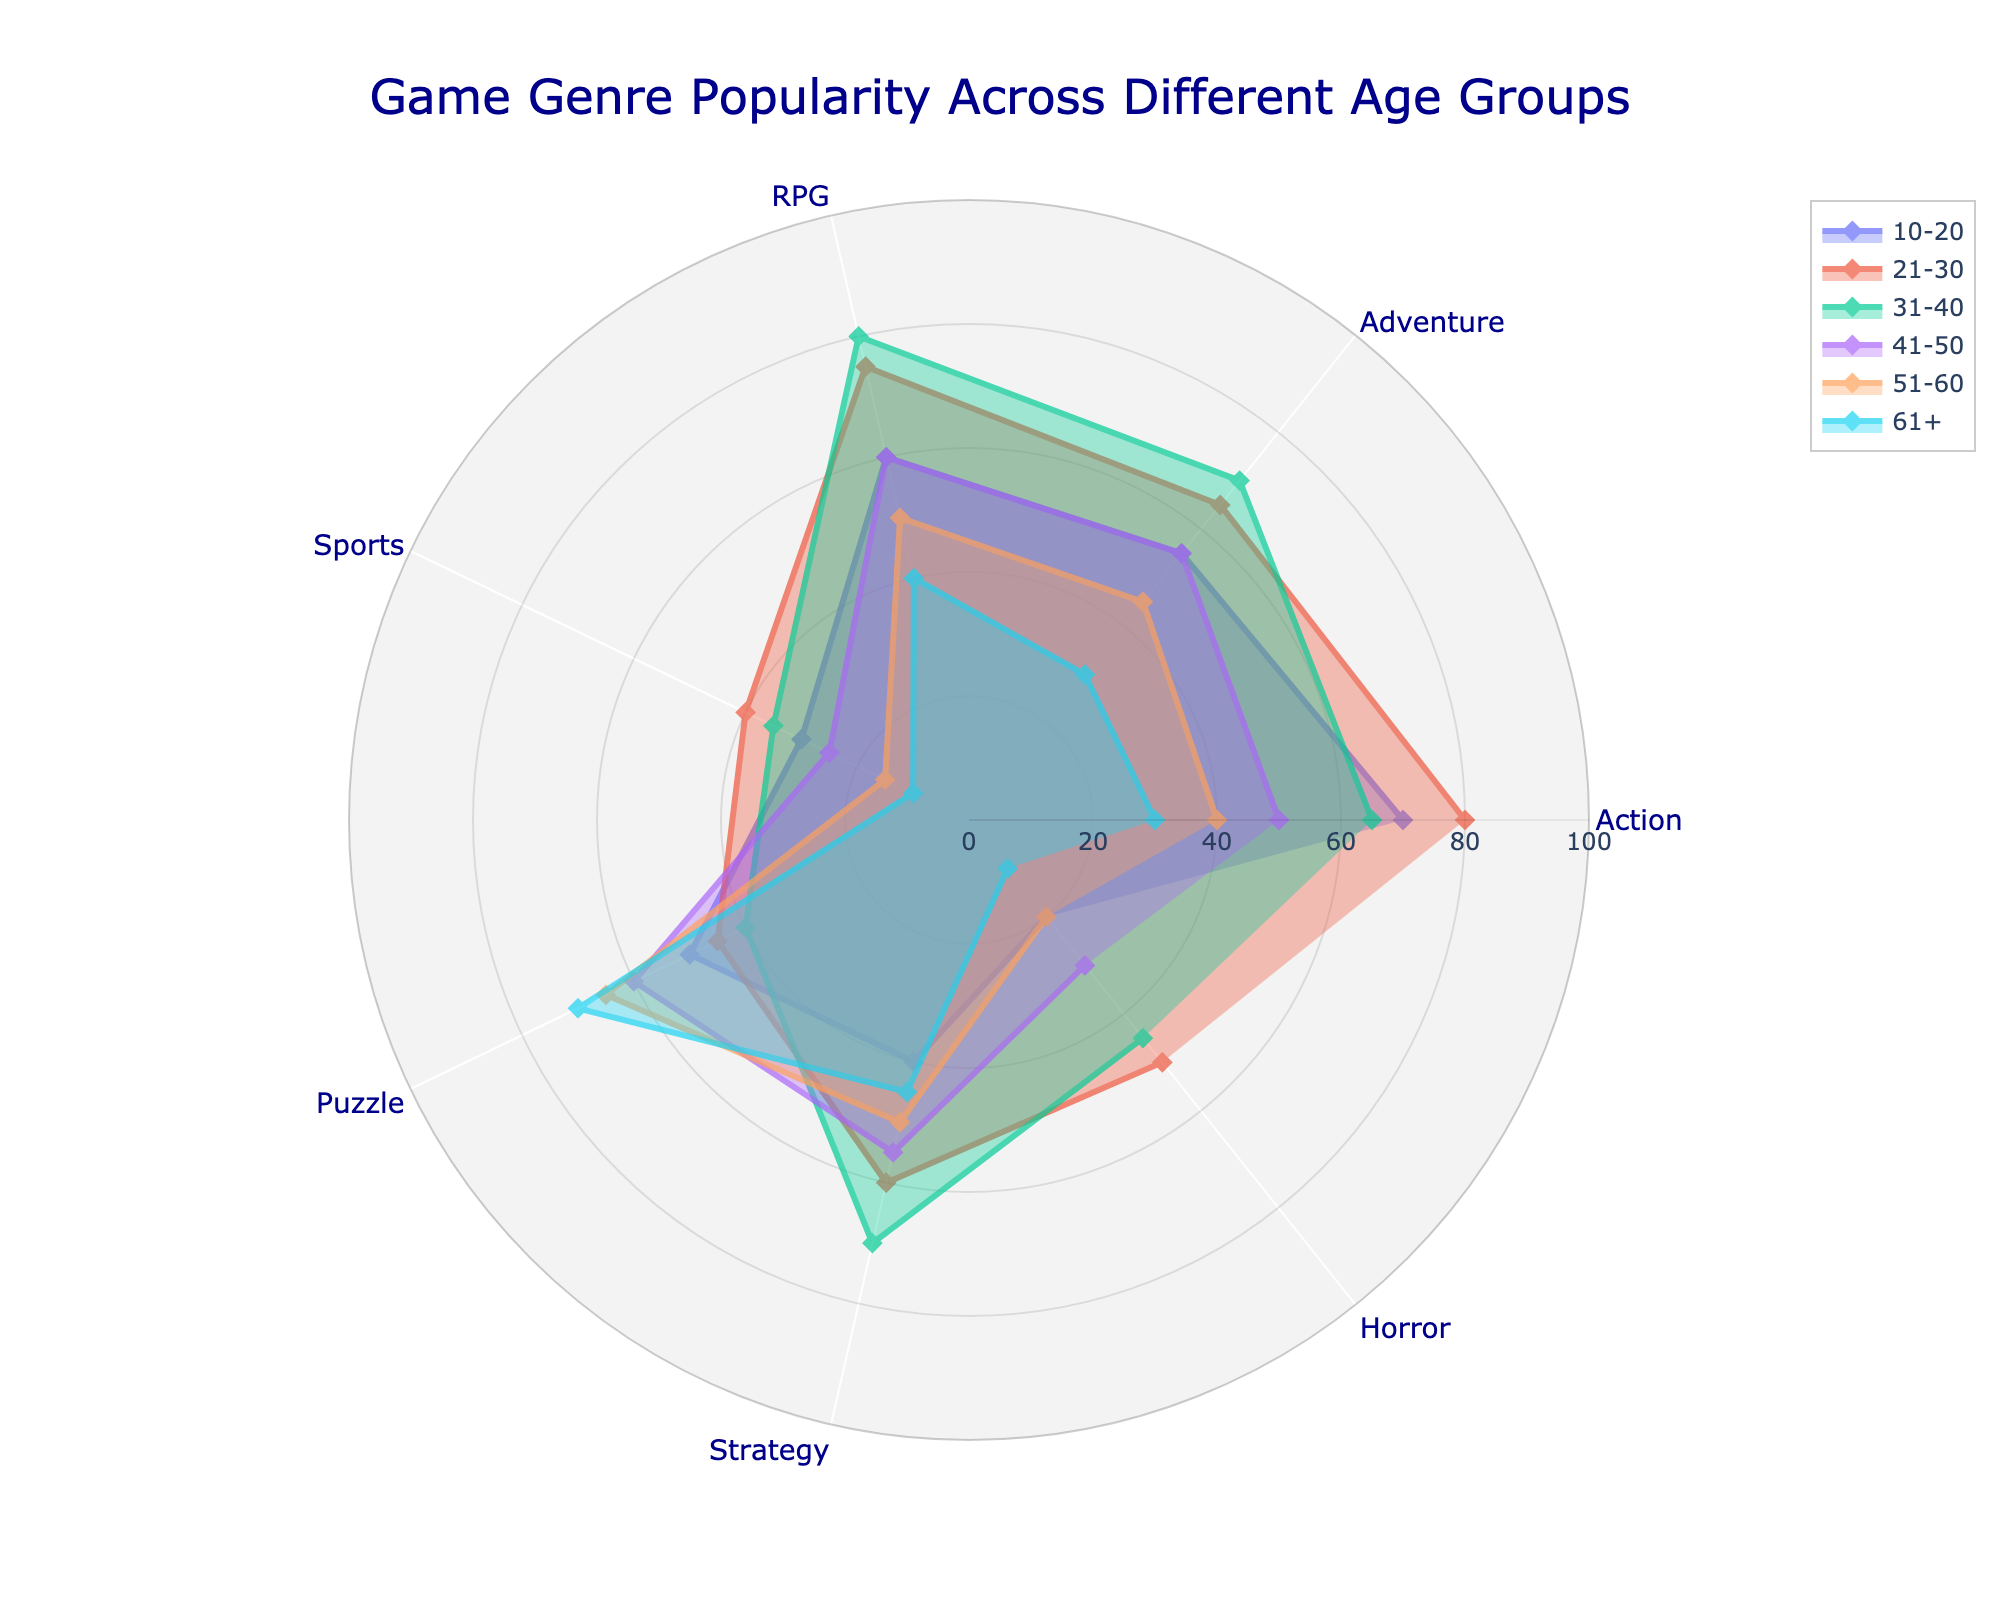what is the title of this radar chart? The title of the radar chart is located at the top and provides an overall understanding of what the chart is depicting. By looking at the top center, the title of the chart can be seen.
Answer: Game Genre Popularity Across Different Age Groups which age group has the highest popularity for RPG games? To find out which age group has the highest popularity for RPG games, we need to look at the radial axis values for the RPG section and identify the age group with the highest value. By examining the figure, we can observe that the 31-40 age group has the highest RPG value.
Answer: 31-40 how does the popularity of horror games differ between the 10-20 and 21-30 age groups? To determine the popularity difference, we need to compare the radial values of the Horror section specifically for the 10-20 age group and the 21-30 age group. The 10-20 age group has a value of 20 and the 21-30 age group has a value of 50.
Answer: 30 which game genre is most popular among the 51-60 age group? To identify the most popular game genre, we look at the segment of the radar chart corresponding to each genre for the 51-60 age group and find the highest value. The highest value in this case is for Puzzle, with a value of 65.
Answer: Puzzle what is the average popularity score for Action games across all age groups? To find the average, we take the sum of the Action game popularity scores across all age groups and divide it by the number of age groups. The scores are 70, 80, 65, 50, 40, and 30, so the average is (70 + 80 + 65 + 50 + 40 + 30) / 6.
Answer: 55 compare the popularity of puzzle games between the 31-40 and 41-50 age groups. Which one has a higher value? We compare the Puzzle genre values for the 31-40 age group and the 41-50 age group by looking at their respective segments. The 31-40 age group has a Puzzle value of 40, while the 41-50 age group has a value of 60.
Answer: 41-50 is there any age group where the popularity of Action games is less than 50? We need to look at the Action segment for each age group and find any instances where the value is less than 50. The 51-60 and 61+ age groups have Action values of 40 and 30, respectively.
Answer: Yes considering the 21-30 age group, what is the difference in popularity between Adventure and Sports games? For the 21-30 age group, we look at the values for Adventure and Sports genres and subtract the Sports value from the Adventure value. The values are 65 for Adventure and 40 for Sports, so the calculation is 65 - 40.
Answer: 25 how does the popularity of Strategy games change from the 41-50 to the 61+ age group? To observe the change, we look at the Strategy values for both age groups and compare them. The 41-50 age group has a value of 55, whereas the 61+ age group has a value of 45, indicating a decrease.
Answer: decreases 